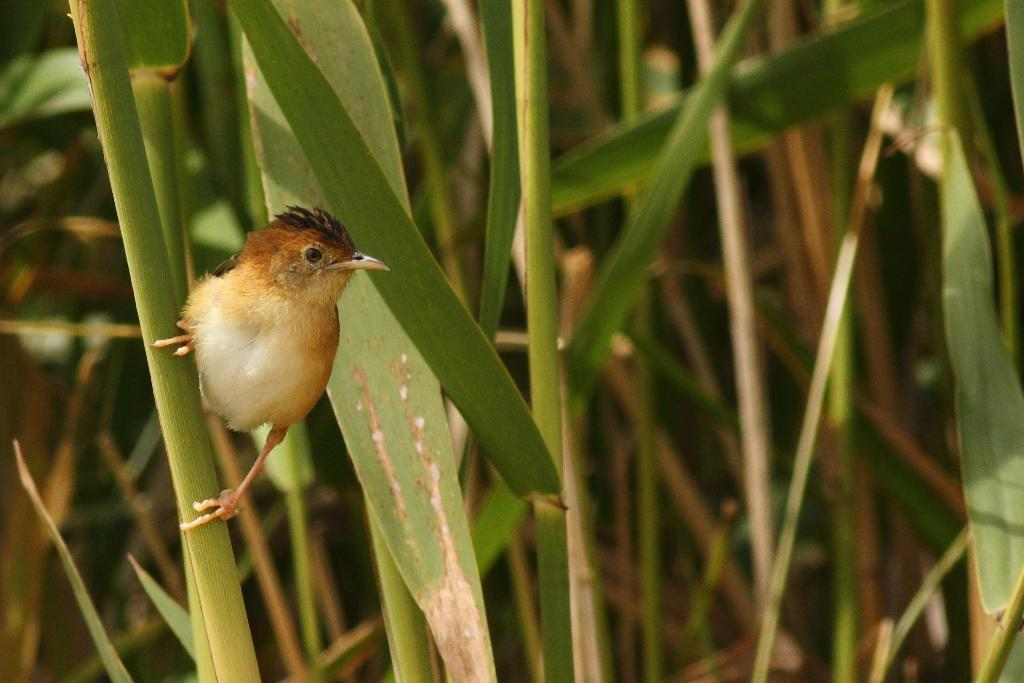What type of animal can be seen in the image? There is a bird in the image. Where is the bird located in the image? The bird is on the left side of the image. What is the bird standing on? The bird is on a leaf. What can be seen in the background of the image? There are plants in the background of the image. How many ladybugs are crawling on the bird in the image? There are no ladybugs present in the image; it only features a bird on a leaf. Can you see an owl in the image? No, there is no owl present in the image; it only features a bird on a leaf. 